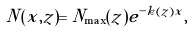<formula> <loc_0><loc_0><loc_500><loc_500>N ( x , z ) = N _ { \max } ( z ) e ^ { - k ( z ) x } ,</formula> 